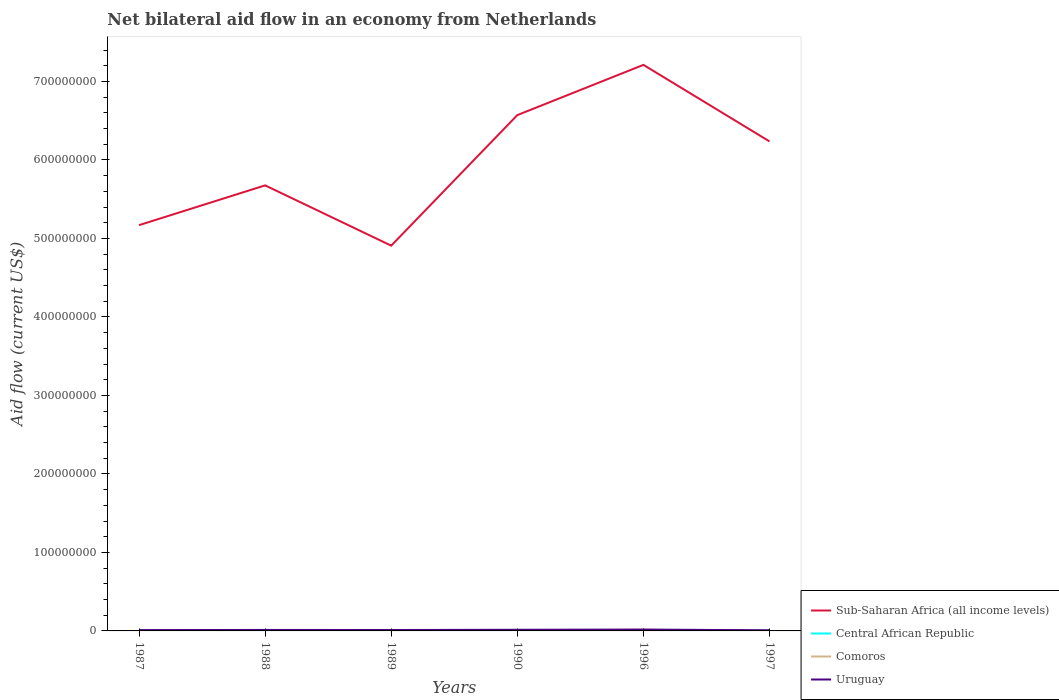How many different coloured lines are there?
Your response must be concise. 4. Across all years, what is the maximum net bilateral aid flow in Comoros?
Offer a terse response. 2.20e+05. In which year was the net bilateral aid flow in Uruguay maximum?
Your answer should be compact. 1997. What is the difference between the highest and the second highest net bilateral aid flow in Uruguay?
Your answer should be very brief. 9.80e+05. What is the difference between the highest and the lowest net bilateral aid flow in Comoros?
Offer a very short reply. 2. Is the net bilateral aid flow in Central African Republic strictly greater than the net bilateral aid flow in Uruguay over the years?
Your response must be concise. Yes. How many years are there in the graph?
Ensure brevity in your answer.  6. What is the difference between two consecutive major ticks on the Y-axis?
Offer a terse response. 1.00e+08. Are the values on the major ticks of Y-axis written in scientific E-notation?
Your answer should be very brief. No. Does the graph contain any zero values?
Your response must be concise. No. Does the graph contain grids?
Keep it short and to the point. No. What is the title of the graph?
Your answer should be compact. Net bilateral aid flow in an economy from Netherlands. Does "Morocco" appear as one of the legend labels in the graph?
Ensure brevity in your answer.  No. What is the label or title of the Y-axis?
Give a very brief answer. Aid flow (current US$). What is the Aid flow (current US$) in Sub-Saharan Africa (all income levels) in 1987?
Ensure brevity in your answer.  5.17e+08. What is the Aid flow (current US$) in Central African Republic in 1987?
Keep it short and to the point. 4.40e+05. What is the Aid flow (current US$) in Uruguay in 1987?
Provide a short and direct response. 1.03e+06. What is the Aid flow (current US$) in Sub-Saharan Africa (all income levels) in 1988?
Ensure brevity in your answer.  5.68e+08. What is the Aid flow (current US$) in Central African Republic in 1988?
Keep it short and to the point. 2.10e+05. What is the Aid flow (current US$) of Comoros in 1988?
Your answer should be very brief. 2.50e+05. What is the Aid flow (current US$) of Uruguay in 1988?
Offer a terse response. 1.26e+06. What is the Aid flow (current US$) of Sub-Saharan Africa (all income levels) in 1989?
Provide a succinct answer. 4.91e+08. What is the Aid flow (current US$) in Central African Republic in 1989?
Your response must be concise. 2.10e+05. What is the Aid flow (current US$) of Uruguay in 1989?
Provide a short and direct response. 1.18e+06. What is the Aid flow (current US$) of Sub-Saharan Africa (all income levels) in 1990?
Offer a very short reply. 6.57e+08. What is the Aid flow (current US$) in Comoros in 1990?
Your response must be concise. 5.80e+05. What is the Aid flow (current US$) of Uruguay in 1990?
Offer a terse response. 1.46e+06. What is the Aid flow (current US$) in Sub-Saharan Africa (all income levels) in 1996?
Your response must be concise. 7.21e+08. What is the Aid flow (current US$) of Central African Republic in 1996?
Keep it short and to the point. 9.20e+05. What is the Aid flow (current US$) in Comoros in 1996?
Make the answer very short. 1.37e+06. What is the Aid flow (current US$) of Uruguay in 1996?
Offer a terse response. 1.76e+06. What is the Aid flow (current US$) in Sub-Saharan Africa (all income levels) in 1997?
Your answer should be very brief. 6.24e+08. What is the Aid flow (current US$) in Central African Republic in 1997?
Provide a short and direct response. 4.50e+05. What is the Aid flow (current US$) in Uruguay in 1997?
Your answer should be very brief. 7.80e+05. Across all years, what is the maximum Aid flow (current US$) in Sub-Saharan Africa (all income levels)?
Provide a short and direct response. 7.21e+08. Across all years, what is the maximum Aid flow (current US$) in Central African Republic?
Provide a short and direct response. 9.20e+05. Across all years, what is the maximum Aid flow (current US$) of Comoros?
Provide a short and direct response. 1.37e+06. Across all years, what is the maximum Aid flow (current US$) in Uruguay?
Give a very brief answer. 1.76e+06. Across all years, what is the minimum Aid flow (current US$) in Sub-Saharan Africa (all income levels)?
Your response must be concise. 4.91e+08. Across all years, what is the minimum Aid flow (current US$) in Central African Republic?
Give a very brief answer. 2.10e+05. Across all years, what is the minimum Aid flow (current US$) in Comoros?
Your answer should be compact. 2.20e+05. Across all years, what is the minimum Aid flow (current US$) in Uruguay?
Offer a very short reply. 7.80e+05. What is the total Aid flow (current US$) in Sub-Saharan Africa (all income levels) in the graph?
Provide a short and direct response. 3.58e+09. What is the total Aid flow (current US$) of Central African Republic in the graph?
Offer a terse response. 2.57e+06. What is the total Aid flow (current US$) of Comoros in the graph?
Ensure brevity in your answer.  3.11e+06. What is the total Aid flow (current US$) in Uruguay in the graph?
Ensure brevity in your answer.  7.47e+06. What is the difference between the Aid flow (current US$) of Sub-Saharan Africa (all income levels) in 1987 and that in 1988?
Provide a succinct answer. -5.07e+07. What is the difference between the Aid flow (current US$) of Central African Republic in 1987 and that in 1988?
Provide a short and direct response. 2.30e+05. What is the difference between the Aid flow (current US$) in Comoros in 1987 and that in 1988?
Provide a short and direct response. -3.00e+04. What is the difference between the Aid flow (current US$) in Sub-Saharan Africa (all income levels) in 1987 and that in 1989?
Keep it short and to the point. 2.61e+07. What is the difference between the Aid flow (current US$) of Sub-Saharan Africa (all income levels) in 1987 and that in 1990?
Keep it short and to the point. -1.40e+08. What is the difference between the Aid flow (current US$) in Comoros in 1987 and that in 1990?
Your answer should be compact. -3.60e+05. What is the difference between the Aid flow (current US$) in Uruguay in 1987 and that in 1990?
Ensure brevity in your answer.  -4.30e+05. What is the difference between the Aid flow (current US$) in Sub-Saharan Africa (all income levels) in 1987 and that in 1996?
Provide a short and direct response. -2.04e+08. What is the difference between the Aid flow (current US$) of Central African Republic in 1987 and that in 1996?
Ensure brevity in your answer.  -4.80e+05. What is the difference between the Aid flow (current US$) of Comoros in 1987 and that in 1996?
Your response must be concise. -1.15e+06. What is the difference between the Aid flow (current US$) in Uruguay in 1987 and that in 1996?
Provide a succinct answer. -7.30e+05. What is the difference between the Aid flow (current US$) in Sub-Saharan Africa (all income levels) in 1987 and that in 1997?
Your response must be concise. -1.07e+08. What is the difference between the Aid flow (current US$) of Uruguay in 1987 and that in 1997?
Offer a terse response. 2.50e+05. What is the difference between the Aid flow (current US$) of Sub-Saharan Africa (all income levels) in 1988 and that in 1989?
Ensure brevity in your answer.  7.68e+07. What is the difference between the Aid flow (current US$) in Uruguay in 1988 and that in 1989?
Give a very brief answer. 8.00e+04. What is the difference between the Aid flow (current US$) in Sub-Saharan Africa (all income levels) in 1988 and that in 1990?
Make the answer very short. -8.95e+07. What is the difference between the Aid flow (current US$) in Comoros in 1988 and that in 1990?
Provide a succinct answer. -3.30e+05. What is the difference between the Aid flow (current US$) in Uruguay in 1988 and that in 1990?
Your answer should be very brief. -2.00e+05. What is the difference between the Aid flow (current US$) of Sub-Saharan Africa (all income levels) in 1988 and that in 1996?
Your response must be concise. -1.54e+08. What is the difference between the Aid flow (current US$) of Central African Republic in 1988 and that in 1996?
Keep it short and to the point. -7.10e+05. What is the difference between the Aid flow (current US$) of Comoros in 1988 and that in 1996?
Offer a terse response. -1.12e+06. What is the difference between the Aid flow (current US$) of Uruguay in 1988 and that in 1996?
Provide a short and direct response. -5.00e+05. What is the difference between the Aid flow (current US$) of Sub-Saharan Africa (all income levels) in 1988 and that in 1997?
Your answer should be very brief. -5.60e+07. What is the difference between the Aid flow (current US$) in Central African Republic in 1988 and that in 1997?
Keep it short and to the point. -2.40e+05. What is the difference between the Aid flow (current US$) in Uruguay in 1988 and that in 1997?
Your answer should be compact. 4.80e+05. What is the difference between the Aid flow (current US$) of Sub-Saharan Africa (all income levels) in 1989 and that in 1990?
Your answer should be very brief. -1.66e+08. What is the difference between the Aid flow (current US$) of Comoros in 1989 and that in 1990?
Offer a very short reply. -3.10e+05. What is the difference between the Aid flow (current US$) in Uruguay in 1989 and that in 1990?
Provide a succinct answer. -2.80e+05. What is the difference between the Aid flow (current US$) in Sub-Saharan Africa (all income levels) in 1989 and that in 1996?
Your response must be concise. -2.30e+08. What is the difference between the Aid flow (current US$) of Central African Republic in 1989 and that in 1996?
Offer a very short reply. -7.10e+05. What is the difference between the Aid flow (current US$) of Comoros in 1989 and that in 1996?
Provide a short and direct response. -1.10e+06. What is the difference between the Aid flow (current US$) in Uruguay in 1989 and that in 1996?
Offer a very short reply. -5.80e+05. What is the difference between the Aid flow (current US$) in Sub-Saharan Africa (all income levels) in 1989 and that in 1997?
Keep it short and to the point. -1.33e+08. What is the difference between the Aid flow (current US$) of Comoros in 1989 and that in 1997?
Offer a very short reply. -1.50e+05. What is the difference between the Aid flow (current US$) in Uruguay in 1989 and that in 1997?
Make the answer very short. 4.00e+05. What is the difference between the Aid flow (current US$) in Sub-Saharan Africa (all income levels) in 1990 and that in 1996?
Your answer should be compact. -6.40e+07. What is the difference between the Aid flow (current US$) in Central African Republic in 1990 and that in 1996?
Keep it short and to the point. -5.80e+05. What is the difference between the Aid flow (current US$) in Comoros in 1990 and that in 1996?
Ensure brevity in your answer.  -7.90e+05. What is the difference between the Aid flow (current US$) of Uruguay in 1990 and that in 1996?
Your answer should be very brief. -3.00e+05. What is the difference between the Aid flow (current US$) of Sub-Saharan Africa (all income levels) in 1990 and that in 1997?
Offer a terse response. 3.35e+07. What is the difference between the Aid flow (current US$) of Central African Republic in 1990 and that in 1997?
Offer a very short reply. -1.10e+05. What is the difference between the Aid flow (current US$) in Comoros in 1990 and that in 1997?
Provide a succinct answer. 1.60e+05. What is the difference between the Aid flow (current US$) of Uruguay in 1990 and that in 1997?
Give a very brief answer. 6.80e+05. What is the difference between the Aid flow (current US$) of Sub-Saharan Africa (all income levels) in 1996 and that in 1997?
Provide a short and direct response. 9.75e+07. What is the difference between the Aid flow (current US$) in Comoros in 1996 and that in 1997?
Keep it short and to the point. 9.50e+05. What is the difference between the Aid flow (current US$) of Uruguay in 1996 and that in 1997?
Keep it short and to the point. 9.80e+05. What is the difference between the Aid flow (current US$) of Sub-Saharan Africa (all income levels) in 1987 and the Aid flow (current US$) of Central African Republic in 1988?
Your answer should be very brief. 5.17e+08. What is the difference between the Aid flow (current US$) in Sub-Saharan Africa (all income levels) in 1987 and the Aid flow (current US$) in Comoros in 1988?
Offer a very short reply. 5.17e+08. What is the difference between the Aid flow (current US$) in Sub-Saharan Africa (all income levels) in 1987 and the Aid flow (current US$) in Uruguay in 1988?
Offer a very short reply. 5.16e+08. What is the difference between the Aid flow (current US$) of Central African Republic in 1987 and the Aid flow (current US$) of Comoros in 1988?
Give a very brief answer. 1.90e+05. What is the difference between the Aid flow (current US$) of Central African Republic in 1987 and the Aid flow (current US$) of Uruguay in 1988?
Give a very brief answer. -8.20e+05. What is the difference between the Aid flow (current US$) of Comoros in 1987 and the Aid flow (current US$) of Uruguay in 1988?
Your response must be concise. -1.04e+06. What is the difference between the Aid flow (current US$) of Sub-Saharan Africa (all income levels) in 1987 and the Aid flow (current US$) of Central African Republic in 1989?
Your answer should be very brief. 5.17e+08. What is the difference between the Aid flow (current US$) of Sub-Saharan Africa (all income levels) in 1987 and the Aid flow (current US$) of Comoros in 1989?
Keep it short and to the point. 5.17e+08. What is the difference between the Aid flow (current US$) in Sub-Saharan Africa (all income levels) in 1987 and the Aid flow (current US$) in Uruguay in 1989?
Offer a very short reply. 5.16e+08. What is the difference between the Aid flow (current US$) in Central African Republic in 1987 and the Aid flow (current US$) in Comoros in 1989?
Ensure brevity in your answer.  1.70e+05. What is the difference between the Aid flow (current US$) of Central African Republic in 1987 and the Aid flow (current US$) of Uruguay in 1989?
Provide a succinct answer. -7.40e+05. What is the difference between the Aid flow (current US$) of Comoros in 1987 and the Aid flow (current US$) of Uruguay in 1989?
Ensure brevity in your answer.  -9.60e+05. What is the difference between the Aid flow (current US$) in Sub-Saharan Africa (all income levels) in 1987 and the Aid flow (current US$) in Central African Republic in 1990?
Your answer should be compact. 5.17e+08. What is the difference between the Aid flow (current US$) in Sub-Saharan Africa (all income levels) in 1987 and the Aid flow (current US$) in Comoros in 1990?
Provide a short and direct response. 5.16e+08. What is the difference between the Aid flow (current US$) of Sub-Saharan Africa (all income levels) in 1987 and the Aid flow (current US$) of Uruguay in 1990?
Give a very brief answer. 5.15e+08. What is the difference between the Aid flow (current US$) in Central African Republic in 1987 and the Aid flow (current US$) in Uruguay in 1990?
Make the answer very short. -1.02e+06. What is the difference between the Aid flow (current US$) of Comoros in 1987 and the Aid flow (current US$) of Uruguay in 1990?
Your answer should be compact. -1.24e+06. What is the difference between the Aid flow (current US$) in Sub-Saharan Africa (all income levels) in 1987 and the Aid flow (current US$) in Central African Republic in 1996?
Your answer should be compact. 5.16e+08. What is the difference between the Aid flow (current US$) of Sub-Saharan Africa (all income levels) in 1987 and the Aid flow (current US$) of Comoros in 1996?
Your answer should be very brief. 5.16e+08. What is the difference between the Aid flow (current US$) in Sub-Saharan Africa (all income levels) in 1987 and the Aid flow (current US$) in Uruguay in 1996?
Your answer should be compact. 5.15e+08. What is the difference between the Aid flow (current US$) in Central African Republic in 1987 and the Aid flow (current US$) in Comoros in 1996?
Your answer should be compact. -9.30e+05. What is the difference between the Aid flow (current US$) of Central African Republic in 1987 and the Aid flow (current US$) of Uruguay in 1996?
Offer a very short reply. -1.32e+06. What is the difference between the Aid flow (current US$) in Comoros in 1987 and the Aid flow (current US$) in Uruguay in 1996?
Give a very brief answer. -1.54e+06. What is the difference between the Aid flow (current US$) in Sub-Saharan Africa (all income levels) in 1987 and the Aid flow (current US$) in Central African Republic in 1997?
Keep it short and to the point. 5.16e+08. What is the difference between the Aid flow (current US$) of Sub-Saharan Africa (all income levels) in 1987 and the Aid flow (current US$) of Comoros in 1997?
Give a very brief answer. 5.17e+08. What is the difference between the Aid flow (current US$) in Sub-Saharan Africa (all income levels) in 1987 and the Aid flow (current US$) in Uruguay in 1997?
Keep it short and to the point. 5.16e+08. What is the difference between the Aid flow (current US$) in Central African Republic in 1987 and the Aid flow (current US$) in Comoros in 1997?
Offer a terse response. 2.00e+04. What is the difference between the Aid flow (current US$) of Central African Republic in 1987 and the Aid flow (current US$) of Uruguay in 1997?
Your answer should be very brief. -3.40e+05. What is the difference between the Aid flow (current US$) in Comoros in 1987 and the Aid flow (current US$) in Uruguay in 1997?
Offer a very short reply. -5.60e+05. What is the difference between the Aid flow (current US$) in Sub-Saharan Africa (all income levels) in 1988 and the Aid flow (current US$) in Central African Republic in 1989?
Ensure brevity in your answer.  5.67e+08. What is the difference between the Aid flow (current US$) in Sub-Saharan Africa (all income levels) in 1988 and the Aid flow (current US$) in Comoros in 1989?
Your response must be concise. 5.67e+08. What is the difference between the Aid flow (current US$) in Sub-Saharan Africa (all income levels) in 1988 and the Aid flow (current US$) in Uruguay in 1989?
Ensure brevity in your answer.  5.66e+08. What is the difference between the Aid flow (current US$) in Central African Republic in 1988 and the Aid flow (current US$) in Comoros in 1989?
Provide a short and direct response. -6.00e+04. What is the difference between the Aid flow (current US$) in Central African Republic in 1988 and the Aid flow (current US$) in Uruguay in 1989?
Offer a terse response. -9.70e+05. What is the difference between the Aid flow (current US$) in Comoros in 1988 and the Aid flow (current US$) in Uruguay in 1989?
Offer a very short reply. -9.30e+05. What is the difference between the Aid flow (current US$) in Sub-Saharan Africa (all income levels) in 1988 and the Aid flow (current US$) in Central African Republic in 1990?
Keep it short and to the point. 5.67e+08. What is the difference between the Aid flow (current US$) in Sub-Saharan Africa (all income levels) in 1988 and the Aid flow (current US$) in Comoros in 1990?
Make the answer very short. 5.67e+08. What is the difference between the Aid flow (current US$) of Sub-Saharan Africa (all income levels) in 1988 and the Aid flow (current US$) of Uruguay in 1990?
Make the answer very short. 5.66e+08. What is the difference between the Aid flow (current US$) in Central African Republic in 1988 and the Aid flow (current US$) in Comoros in 1990?
Ensure brevity in your answer.  -3.70e+05. What is the difference between the Aid flow (current US$) in Central African Republic in 1988 and the Aid flow (current US$) in Uruguay in 1990?
Offer a very short reply. -1.25e+06. What is the difference between the Aid flow (current US$) in Comoros in 1988 and the Aid flow (current US$) in Uruguay in 1990?
Offer a terse response. -1.21e+06. What is the difference between the Aid flow (current US$) of Sub-Saharan Africa (all income levels) in 1988 and the Aid flow (current US$) of Central African Republic in 1996?
Your answer should be very brief. 5.67e+08. What is the difference between the Aid flow (current US$) of Sub-Saharan Africa (all income levels) in 1988 and the Aid flow (current US$) of Comoros in 1996?
Provide a succinct answer. 5.66e+08. What is the difference between the Aid flow (current US$) of Sub-Saharan Africa (all income levels) in 1988 and the Aid flow (current US$) of Uruguay in 1996?
Provide a short and direct response. 5.66e+08. What is the difference between the Aid flow (current US$) in Central African Republic in 1988 and the Aid flow (current US$) in Comoros in 1996?
Your answer should be very brief. -1.16e+06. What is the difference between the Aid flow (current US$) in Central African Republic in 1988 and the Aid flow (current US$) in Uruguay in 1996?
Give a very brief answer. -1.55e+06. What is the difference between the Aid flow (current US$) of Comoros in 1988 and the Aid flow (current US$) of Uruguay in 1996?
Keep it short and to the point. -1.51e+06. What is the difference between the Aid flow (current US$) in Sub-Saharan Africa (all income levels) in 1988 and the Aid flow (current US$) in Central African Republic in 1997?
Make the answer very short. 5.67e+08. What is the difference between the Aid flow (current US$) in Sub-Saharan Africa (all income levels) in 1988 and the Aid flow (current US$) in Comoros in 1997?
Keep it short and to the point. 5.67e+08. What is the difference between the Aid flow (current US$) in Sub-Saharan Africa (all income levels) in 1988 and the Aid flow (current US$) in Uruguay in 1997?
Keep it short and to the point. 5.67e+08. What is the difference between the Aid flow (current US$) in Central African Republic in 1988 and the Aid flow (current US$) in Comoros in 1997?
Make the answer very short. -2.10e+05. What is the difference between the Aid flow (current US$) in Central African Republic in 1988 and the Aid flow (current US$) in Uruguay in 1997?
Ensure brevity in your answer.  -5.70e+05. What is the difference between the Aid flow (current US$) in Comoros in 1988 and the Aid flow (current US$) in Uruguay in 1997?
Offer a terse response. -5.30e+05. What is the difference between the Aid flow (current US$) in Sub-Saharan Africa (all income levels) in 1989 and the Aid flow (current US$) in Central African Republic in 1990?
Offer a terse response. 4.90e+08. What is the difference between the Aid flow (current US$) in Sub-Saharan Africa (all income levels) in 1989 and the Aid flow (current US$) in Comoros in 1990?
Give a very brief answer. 4.90e+08. What is the difference between the Aid flow (current US$) in Sub-Saharan Africa (all income levels) in 1989 and the Aid flow (current US$) in Uruguay in 1990?
Provide a succinct answer. 4.89e+08. What is the difference between the Aid flow (current US$) in Central African Republic in 1989 and the Aid flow (current US$) in Comoros in 1990?
Your answer should be very brief. -3.70e+05. What is the difference between the Aid flow (current US$) of Central African Republic in 1989 and the Aid flow (current US$) of Uruguay in 1990?
Provide a short and direct response. -1.25e+06. What is the difference between the Aid flow (current US$) in Comoros in 1989 and the Aid flow (current US$) in Uruguay in 1990?
Your answer should be compact. -1.19e+06. What is the difference between the Aid flow (current US$) of Sub-Saharan Africa (all income levels) in 1989 and the Aid flow (current US$) of Central African Republic in 1996?
Keep it short and to the point. 4.90e+08. What is the difference between the Aid flow (current US$) in Sub-Saharan Africa (all income levels) in 1989 and the Aid flow (current US$) in Comoros in 1996?
Your answer should be very brief. 4.89e+08. What is the difference between the Aid flow (current US$) in Sub-Saharan Africa (all income levels) in 1989 and the Aid flow (current US$) in Uruguay in 1996?
Ensure brevity in your answer.  4.89e+08. What is the difference between the Aid flow (current US$) of Central African Republic in 1989 and the Aid flow (current US$) of Comoros in 1996?
Your answer should be compact. -1.16e+06. What is the difference between the Aid flow (current US$) of Central African Republic in 1989 and the Aid flow (current US$) of Uruguay in 1996?
Make the answer very short. -1.55e+06. What is the difference between the Aid flow (current US$) of Comoros in 1989 and the Aid flow (current US$) of Uruguay in 1996?
Offer a very short reply. -1.49e+06. What is the difference between the Aid flow (current US$) in Sub-Saharan Africa (all income levels) in 1989 and the Aid flow (current US$) in Central African Republic in 1997?
Offer a terse response. 4.90e+08. What is the difference between the Aid flow (current US$) in Sub-Saharan Africa (all income levels) in 1989 and the Aid flow (current US$) in Comoros in 1997?
Your answer should be very brief. 4.90e+08. What is the difference between the Aid flow (current US$) in Sub-Saharan Africa (all income levels) in 1989 and the Aid flow (current US$) in Uruguay in 1997?
Your response must be concise. 4.90e+08. What is the difference between the Aid flow (current US$) of Central African Republic in 1989 and the Aid flow (current US$) of Uruguay in 1997?
Make the answer very short. -5.70e+05. What is the difference between the Aid flow (current US$) of Comoros in 1989 and the Aid flow (current US$) of Uruguay in 1997?
Make the answer very short. -5.10e+05. What is the difference between the Aid flow (current US$) in Sub-Saharan Africa (all income levels) in 1990 and the Aid flow (current US$) in Central African Republic in 1996?
Provide a short and direct response. 6.56e+08. What is the difference between the Aid flow (current US$) in Sub-Saharan Africa (all income levels) in 1990 and the Aid flow (current US$) in Comoros in 1996?
Give a very brief answer. 6.56e+08. What is the difference between the Aid flow (current US$) in Sub-Saharan Africa (all income levels) in 1990 and the Aid flow (current US$) in Uruguay in 1996?
Provide a succinct answer. 6.55e+08. What is the difference between the Aid flow (current US$) of Central African Republic in 1990 and the Aid flow (current US$) of Comoros in 1996?
Give a very brief answer. -1.03e+06. What is the difference between the Aid flow (current US$) of Central African Republic in 1990 and the Aid flow (current US$) of Uruguay in 1996?
Your answer should be very brief. -1.42e+06. What is the difference between the Aid flow (current US$) in Comoros in 1990 and the Aid flow (current US$) in Uruguay in 1996?
Provide a succinct answer. -1.18e+06. What is the difference between the Aid flow (current US$) of Sub-Saharan Africa (all income levels) in 1990 and the Aid flow (current US$) of Central African Republic in 1997?
Make the answer very short. 6.57e+08. What is the difference between the Aid flow (current US$) in Sub-Saharan Africa (all income levels) in 1990 and the Aid flow (current US$) in Comoros in 1997?
Provide a short and direct response. 6.57e+08. What is the difference between the Aid flow (current US$) in Sub-Saharan Africa (all income levels) in 1990 and the Aid flow (current US$) in Uruguay in 1997?
Your answer should be very brief. 6.56e+08. What is the difference between the Aid flow (current US$) in Central African Republic in 1990 and the Aid flow (current US$) in Comoros in 1997?
Offer a very short reply. -8.00e+04. What is the difference between the Aid flow (current US$) in Central African Republic in 1990 and the Aid flow (current US$) in Uruguay in 1997?
Ensure brevity in your answer.  -4.40e+05. What is the difference between the Aid flow (current US$) of Comoros in 1990 and the Aid flow (current US$) of Uruguay in 1997?
Provide a succinct answer. -2.00e+05. What is the difference between the Aid flow (current US$) of Sub-Saharan Africa (all income levels) in 1996 and the Aid flow (current US$) of Central African Republic in 1997?
Your answer should be very brief. 7.21e+08. What is the difference between the Aid flow (current US$) in Sub-Saharan Africa (all income levels) in 1996 and the Aid flow (current US$) in Comoros in 1997?
Offer a terse response. 7.21e+08. What is the difference between the Aid flow (current US$) of Sub-Saharan Africa (all income levels) in 1996 and the Aid flow (current US$) of Uruguay in 1997?
Keep it short and to the point. 7.20e+08. What is the difference between the Aid flow (current US$) of Central African Republic in 1996 and the Aid flow (current US$) of Uruguay in 1997?
Your answer should be very brief. 1.40e+05. What is the difference between the Aid flow (current US$) in Comoros in 1996 and the Aid flow (current US$) in Uruguay in 1997?
Offer a terse response. 5.90e+05. What is the average Aid flow (current US$) of Sub-Saharan Africa (all income levels) per year?
Give a very brief answer. 5.96e+08. What is the average Aid flow (current US$) in Central African Republic per year?
Offer a very short reply. 4.28e+05. What is the average Aid flow (current US$) of Comoros per year?
Offer a terse response. 5.18e+05. What is the average Aid flow (current US$) in Uruguay per year?
Your response must be concise. 1.24e+06. In the year 1987, what is the difference between the Aid flow (current US$) of Sub-Saharan Africa (all income levels) and Aid flow (current US$) of Central African Republic?
Ensure brevity in your answer.  5.16e+08. In the year 1987, what is the difference between the Aid flow (current US$) in Sub-Saharan Africa (all income levels) and Aid flow (current US$) in Comoros?
Offer a very short reply. 5.17e+08. In the year 1987, what is the difference between the Aid flow (current US$) of Sub-Saharan Africa (all income levels) and Aid flow (current US$) of Uruguay?
Give a very brief answer. 5.16e+08. In the year 1987, what is the difference between the Aid flow (current US$) in Central African Republic and Aid flow (current US$) in Uruguay?
Make the answer very short. -5.90e+05. In the year 1987, what is the difference between the Aid flow (current US$) of Comoros and Aid flow (current US$) of Uruguay?
Your answer should be very brief. -8.10e+05. In the year 1988, what is the difference between the Aid flow (current US$) of Sub-Saharan Africa (all income levels) and Aid flow (current US$) of Central African Republic?
Your answer should be very brief. 5.67e+08. In the year 1988, what is the difference between the Aid flow (current US$) in Sub-Saharan Africa (all income levels) and Aid flow (current US$) in Comoros?
Provide a short and direct response. 5.67e+08. In the year 1988, what is the difference between the Aid flow (current US$) in Sub-Saharan Africa (all income levels) and Aid flow (current US$) in Uruguay?
Give a very brief answer. 5.66e+08. In the year 1988, what is the difference between the Aid flow (current US$) of Central African Republic and Aid flow (current US$) of Uruguay?
Provide a short and direct response. -1.05e+06. In the year 1988, what is the difference between the Aid flow (current US$) in Comoros and Aid flow (current US$) in Uruguay?
Keep it short and to the point. -1.01e+06. In the year 1989, what is the difference between the Aid flow (current US$) in Sub-Saharan Africa (all income levels) and Aid flow (current US$) in Central African Republic?
Give a very brief answer. 4.91e+08. In the year 1989, what is the difference between the Aid flow (current US$) of Sub-Saharan Africa (all income levels) and Aid flow (current US$) of Comoros?
Your response must be concise. 4.91e+08. In the year 1989, what is the difference between the Aid flow (current US$) in Sub-Saharan Africa (all income levels) and Aid flow (current US$) in Uruguay?
Offer a very short reply. 4.90e+08. In the year 1989, what is the difference between the Aid flow (current US$) in Central African Republic and Aid flow (current US$) in Comoros?
Provide a short and direct response. -6.00e+04. In the year 1989, what is the difference between the Aid flow (current US$) in Central African Republic and Aid flow (current US$) in Uruguay?
Offer a very short reply. -9.70e+05. In the year 1989, what is the difference between the Aid flow (current US$) in Comoros and Aid flow (current US$) in Uruguay?
Provide a succinct answer. -9.10e+05. In the year 1990, what is the difference between the Aid flow (current US$) in Sub-Saharan Africa (all income levels) and Aid flow (current US$) in Central African Republic?
Your answer should be compact. 6.57e+08. In the year 1990, what is the difference between the Aid flow (current US$) in Sub-Saharan Africa (all income levels) and Aid flow (current US$) in Comoros?
Your answer should be compact. 6.57e+08. In the year 1990, what is the difference between the Aid flow (current US$) in Sub-Saharan Africa (all income levels) and Aid flow (current US$) in Uruguay?
Keep it short and to the point. 6.56e+08. In the year 1990, what is the difference between the Aid flow (current US$) in Central African Republic and Aid flow (current US$) in Uruguay?
Offer a very short reply. -1.12e+06. In the year 1990, what is the difference between the Aid flow (current US$) of Comoros and Aid flow (current US$) of Uruguay?
Give a very brief answer. -8.80e+05. In the year 1996, what is the difference between the Aid flow (current US$) in Sub-Saharan Africa (all income levels) and Aid flow (current US$) in Central African Republic?
Your answer should be compact. 7.20e+08. In the year 1996, what is the difference between the Aid flow (current US$) in Sub-Saharan Africa (all income levels) and Aid flow (current US$) in Comoros?
Your response must be concise. 7.20e+08. In the year 1996, what is the difference between the Aid flow (current US$) of Sub-Saharan Africa (all income levels) and Aid flow (current US$) of Uruguay?
Your response must be concise. 7.19e+08. In the year 1996, what is the difference between the Aid flow (current US$) in Central African Republic and Aid flow (current US$) in Comoros?
Give a very brief answer. -4.50e+05. In the year 1996, what is the difference between the Aid flow (current US$) in Central African Republic and Aid flow (current US$) in Uruguay?
Ensure brevity in your answer.  -8.40e+05. In the year 1996, what is the difference between the Aid flow (current US$) in Comoros and Aid flow (current US$) in Uruguay?
Your response must be concise. -3.90e+05. In the year 1997, what is the difference between the Aid flow (current US$) of Sub-Saharan Africa (all income levels) and Aid flow (current US$) of Central African Republic?
Ensure brevity in your answer.  6.23e+08. In the year 1997, what is the difference between the Aid flow (current US$) in Sub-Saharan Africa (all income levels) and Aid flow (current US$) in Comoros?
Provide a succinct answer. 6.23e+08. In the year 1997, what is the difference between the Aid flow (current US$) in Sub-Saharan Africa (all income levels) and Aid flow (current US$) in Uruguay?
Ensure brevity in your answer.  6.23e+08. In the year 1997, what is the difference between the Aid flow (current US$) of Central African Republic and Aid flow (current US$) of Comoros?
Make the answer very short. 3.00e+04. In the year 1997, what is the difference between the Aid flow (current US$) in Central African Republic and Aid flow (current US$) in Uruguay?
Your answer should be compact. -3.30e+05. In the year 1997, what is the difference between the Aid flow (current US$) of Comoros and Aid flow (current US$) of Uruguay?
Give a very brief answer. -3.60e+05. What is the ratio of the Aid flow (current US$) of Sub-Saharan Africa (all income levels) in 1987 to that in 1988?
Offer a very short reply. 0.91. What is the ratio of the Aid flow (current US$) in Central African Republic in 1987 to that in 1988?
Offer a very short reply. 2.1. What is the ratio of the Aid flow (current US$) in Uruguay in 1987 to that in 1988?
Keep it short and to the point. 0.82. What is the ratio of the Aid flow (current US$) of Sub-Saharan Africa (all income levels) in 1987 to that in 1989?
Make the answer very short. 1.05. What is the ratio of the Aid flow (current US$) in Central African Republic in 1987 to that in 1989?
Provide a succinct answer. 2.1. What is the ratio of the Aid flow (current US$) in Comoros in 1987 to that in 1989?
Your response must be concise. 0.81. What is the ratio of the Aid flow (current US$) of Uruguay in 1987 to that in 1989?
Ensure brevity in your answer.  0.87. What is the ratio of the Aid flow (current US$) in Sub-Saharan Africa (all income levels) in 1987 to that in 1990?
Ensure brevity in your answer.  0.79. What is the ratio of the Aid flow (current US$) of Central African Republic in 1987 to that in 1990?
Keep it short and to the point. 1.29. What is the ratio of the Aid flow (current US$) of Comoros in 1987 to that in 1990?
Provide a short and direct response. 0.38. What is the ratio of the Aid flow (current US$) of Uruguay in 1987 to that in 1990?
Make the answer very short. 0.71. What is the ratio of the Aid flow (current US$) of Sub-Saharan Africa (all income levels) in 1987 to that in 1996?
Give a very brief answer. 0.72. What is the ratio of the Aid flow (current US$) of Central African Republic in 1987 to that in 1996?
Give a very brief answer. 0.48. What is the ratio of the Aid flow (current US$) of Comoros in 1987 to that in 1996?
Your answer should be compact. 0.16. What is the ratio of the Aid flow (current US$) of Uruguay in 1987 to that in 1996?
Make the answer very short. 0.59. What is the ratio of the Aid flow (current US$) of Sub-Saharan Africa (all income levels) in 1987 to that in 1997?
Give a very brief answer. 0.83. What is the ratio of the Aid flow (current US$) of Central African Republic in 1987 to that in 1997?
Your answer should be very brief. 0.98. What is the ratio of the Aid flow (current US$) in Comoros in 1987 to that in 1997?
Your answer should be very brief. 0.52. What is the ratio of the Aid flow (current US$) of Uruguay in 1987 to that in 1997?
Keep it short and to the point. 1.32. What is the ratio of the Aid flow (current US$) of Sub-Saharan Africa (all income levels) in 1988 to that in 1989?
Make the answer very short. 1.16. What is the ratio of the Aid flow (current US$) in Central African Republic in 1988 to that in 1989?
Offer a terse response. 1. What is the ratio of the Aid flow (current US$) in Comoros in 1988 to that in 1989?
Give a very brief answer. 0.93. What is the ratio of the Aid flow (current US$) in Uruguay in 1988 to that in 1989?
Offer a terse response. 1.07. What is the ratio of the Aid flow (current US$) in Sub-Saharan Africa (all income levels) in 1988 to that in 1990?
Your answer should be very brief. 0.86. What is the ratio of the Aid flow (current US$) of Central African Republic in 1988 to that in 1990?
Offer a terse response. 0.62. What is the ratio of the Aid flow (current US$) in Comoros in 1988 to that in 1990?
Your response must be concise. 0.43. What is the ratio of the Aid flow (current US$) of Uruguay in 1988 to that in 1990?
Your response must be concise. 0.86. What is the ratio of the Aid flow (current US$) in Sub-Saharan Africa (all income levels) in 1988 to that in 1996?
Ensure brevity in your answer.  0.79. What is the ratio of the Aid flow (current US$) in Central African Republic in 1988 to that in 1996?
Provide a short and direct response. 0.23. What is the ratio of the Aid flow (current US$) in Comoros in 1988 to that in 1996?
Keep it short and to the point. 0.18. What is the ratio of the Aid flow (current US$) of Uruguay in 1988 to that in 1996?
Provide a succinct answer. 0.72. What is the ratio of the Aid flow (current US$) in Sub-Saharan Africa (all income levels) in 1988 to that in 1997?
Your response must be concise. 0.91. What is the ratio of the Aid flow (current US$) of Central African Republic in 1988 to that in 1997?
Give a very brief answer. 0.47. What is the ratio of the Aid flow (current US$) in Comoros in 1988 to that in 1997?
Your answer should be very brief. 0.6. What is the ratio of the Aid flow (current US$) of Uruguay in 1988 to that in 1997?
Your answer should be compact. 1.62. What is the ratio of the Aid flow (current US$) of Sub-Saharan Africa (all income levels) in 1989 to that in 1990?
Keep it short and to the point. 0.75. What is the ratio of the Aid flow (current US$) of Central African Republic in 1989 to that in 1990?
Give a very brief answer. 0.62. What is the ratio of the Aid flow (current US$) in Comoros in 1989 to that in 1990?
Offer a very short reply. 0.47. What is the ratio of the Aid flow (current US$) in Uruguay in 1989 to that in 1990?
Your response must be concise. 0.81. What is the ratio of the Aid flow (current US$) in Sub-Saharan Africa (all income levels) in 1989 to that in 1996?
Your answer should be very brief. 0.68. What is the ratio of the Aid flow (current US$) in Central African Republic in 1989 to that in 1996?
Keep it short and to the point. 0.23. What is the ratio of the Aid flow (current US$) in Comoros in 1989 to that in 1996?
Your response must be concise. 0.2. What is the ratio of the Aid flow (current US$) of Uruguay in 1989 to that in 1996?
Offer a very short reply. 0.67. What is the ratio of the Aid flow (current US$) of Sub-Saharan Africa (all income levels) in 1989 to that in 1997?
Your response must be concise. 0.79. What is the ratio of the Aid flow (current US$) in Central African Republic in 1989 to that in 1997?
Offer a terse response. 0.47. What is the ratio of the Aid flow (current US$) of Comoros in 1989 to that in 1997?
Provide a short and direct response. 0.64. What is the ratio of the Aid flow (current US$) of Uruguay in 1989 to that in 1997?
Your response must be concise. 1.51. What is the ratio of the Aid flow (current US$) in Sub-Saharan Africa (all income levels) in 1990 to that in 1996?
Make the answer very short. 0.91. What is the ratio of the Aid flow (current US$) in Central African Republic in 1990 to that in 1996?
Offer a terse response. 0.37. What is the ratio of the Aid flow (current US$) of Comoros in 1990 to that in 1996?
Provide a short and direct response. 0.42. What is the ratio of the Aid flow (current US$) in Uruguay in 1990 to that in 1996?
Your answer should be very brief. 0.83. What is the ratio of the Aid flow (current US$) of Sub-Saharan Africa (all income levels) in 1990 to that in 1997?
Your answer should be compact. 1.05. What is the ratio of the Aid flow (current US$) of Central African Republic in 1990 to that in 1997?
Make the answer very short. 0.76. What is the ratio of the Aid flow (current US$) in Comoros in 1990 to that in 1997?
Provide a short and direct response. 1.38. What is the ratio of the Aid flow (current US$) in Uruguay in 1990 to that in 1997?
Offer a terse response. 1.87. What is the ratio of the Aid flow (current US$) of Sub-Saharan Africa (all income levels) in 1996 to that in 1997?
Your answer should be very brief. 1.16. What is the ratio of the Aid flow (current US$) of Central African Republic in 1996 to that in 1997?
Your response must be concise. 2.04. What is the ratio of the Aid flow (current US$) in Comoros in 1996 to that in 1997?
Make the answer very short. 3.26. What is the ratio of the Aid flow (current US$) in Uruguay in 1996 to that in 1997?
Keep it short and to the point. 2.26. What is the difference between the highest and the second highest Aid flow (current US$) of Sub-Saharan Africa (all income levels)?
Make the answer very short. 6.40e+07. What is the difference between the highest and the second highest Aid flow (current US$) in Central African Republic?
Your answer should be compact. 4.70e+05. What is the difference between the highest and the second highest Aid flow (current US$) in Comoros?
Give a very brief answer. 7.90e+05. What is the difference between the highest and the second highest Aid flow (current US$) in Uruguay?
Provide a short and direct response. 3.00e+05. What is the difference between the highest and the lowest Aid flow (current US$) of Sub-Saharan Africa (all income levels)?
Ensure brevity in your answer.  2.30e+08. What is the difference between the highest and the lowest Aid flow (current US$) in Central African Republic?
Provide a succinct answer. 7.10e+05. What is the difference between the highest and the lowest Aid flow (current US$) in Comoros?
Ensure brevity in your answer.  1.15e+06. What is the difference between the highest and the lowest Aid flow (current US$) in Uruguay?
Give a very brief answer. 9.80e+05. 